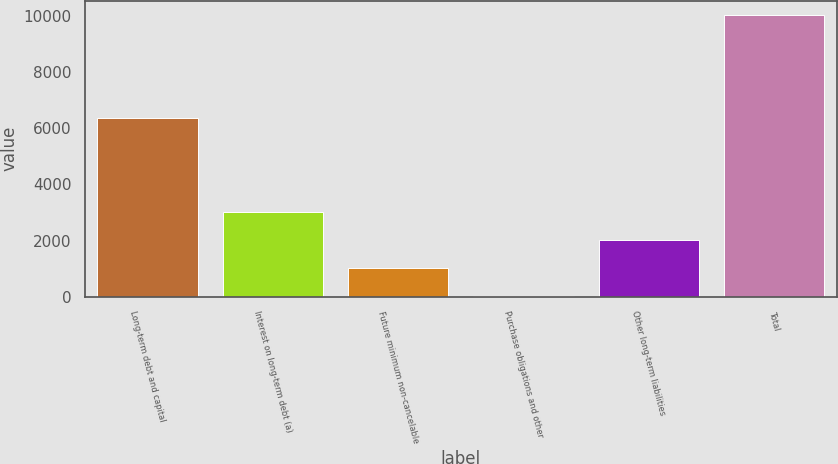Convert chart. <chart><loc_0><loc_0><loc_500><loc_500><bar_chart><fcel>Long-term debt and capital<fcel>Interest on long-term debt (a)<fcel>Future minimum non-cancelable<fcel>Purchase obligations and other<fcel>Other long-term liabilities<fcel>Total<nl><fcel>6370<fcel>3026.1<fcel>1022.7<fcel>21<fcel>2024.4<fcel>10038<nl></chart> 